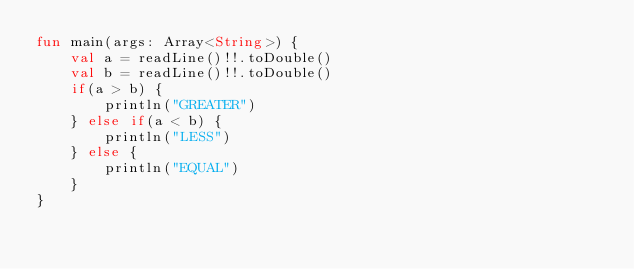<code> <loc_0><loc_0><loc_500><loc_500><_Kotlin_>fun main(args: Array<String>) {
    val a = readLine()!!.toDouble()
    val b = readLine()!!.toDouble()
    if(a > b) {
        println("GREATER")
    } else if(a < b) {
        println("LESS")
    } else {
        println("EQUAL")
    }
}</code> 